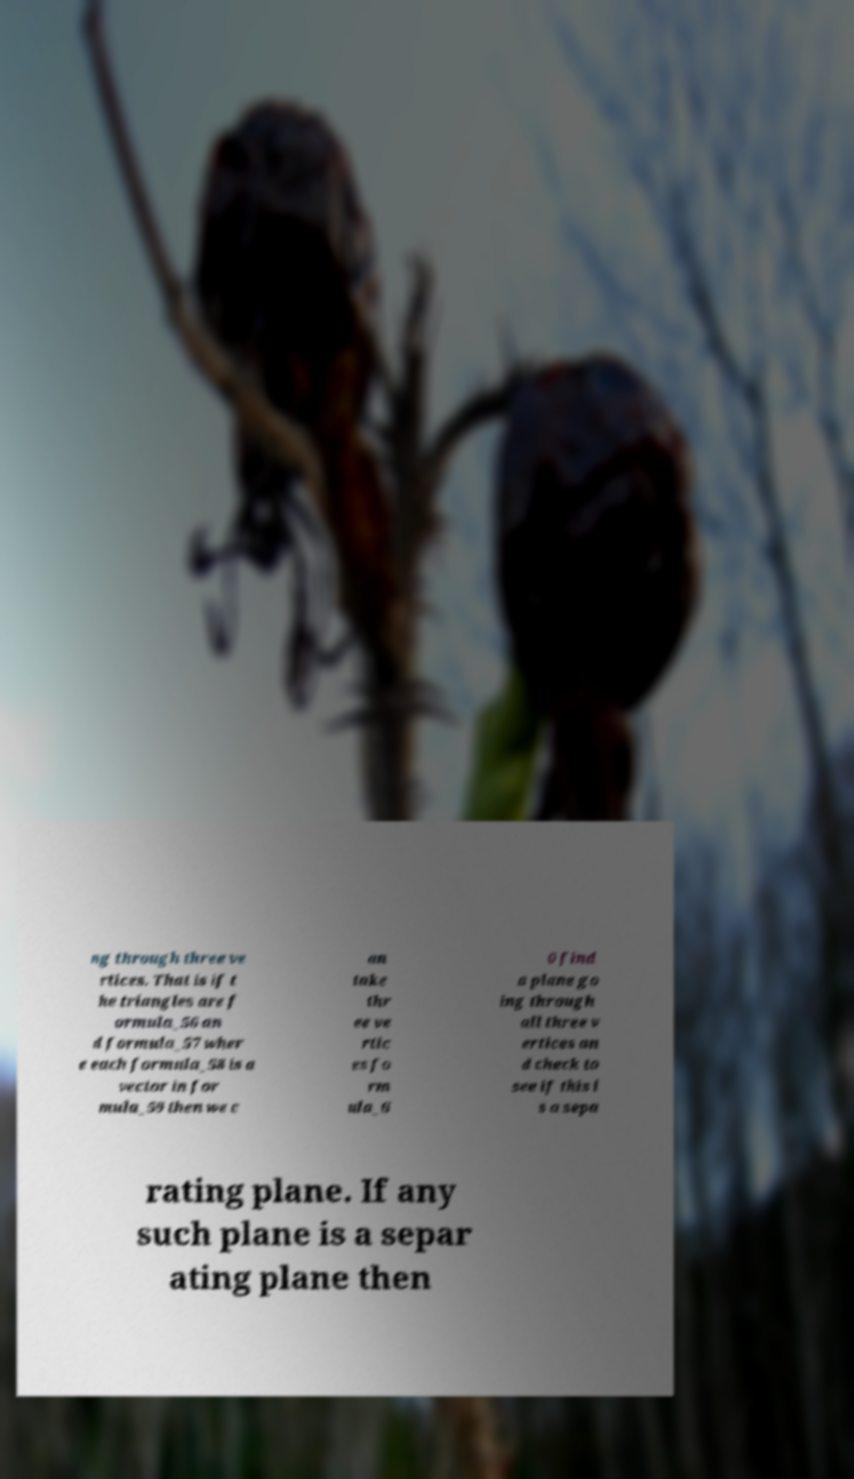For documentation purposes, I need the text within this image transcribed. Could you provide that? ng through three ve rtices. That is if t he triangles are f ormula_56 an d formula_57 wher e each formula_58 is a vector in for mula_59 then we c an take thr ee ve rtic es fo rm ula_6 0 find a plane go ing through all three v ertices an d check to see if this i s a sepa rating plane. If any such plane is a separ ating plane then 